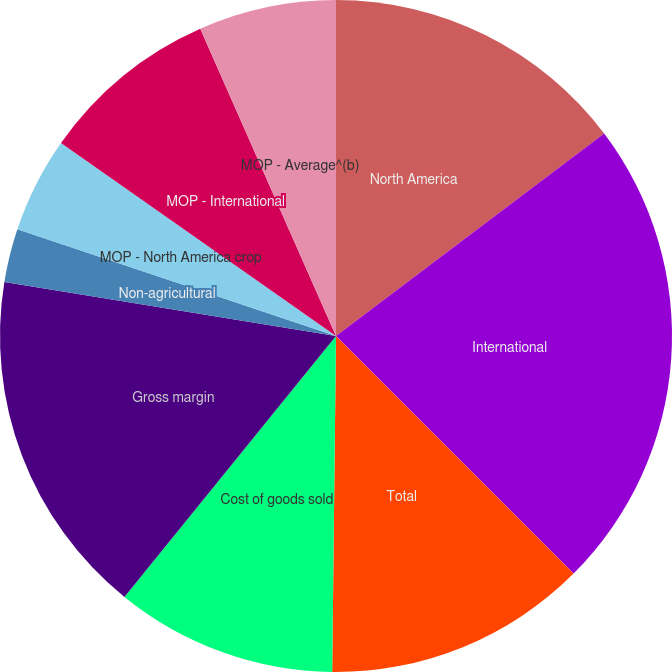Convert chart. <chart><loc_0><loc_0><loc_500><loc_500><pie_chart><fcel>North America<fcel>International<fcel>Total<fcel>Cost of goods sold<fcel>Gross margin<fcel>Non-agricultural<fcel>MOP - North America crop<fcel>MOP - International<fcel>MOP - Average^(b)<nl><fcel>14.71%<fcel>22.79%<fcel>12.68%<fcel>10.66%<fcel>16.73%<fcel>2.57%<fcel>4.6%<fcel>8.64%<fcel>6.62%<nl></chart> 